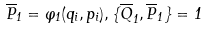Convert formula to latex. <formula><loc_0><loc_0><loc_500><loc_500>\overline { P } _ { 1 } = \varphi _ { 1 } ( q _ { i } , p _ { i } ) , \{ \overline { Q } _ { 1 } , \overline { P } _ { 1 } \} = 1</formula> 